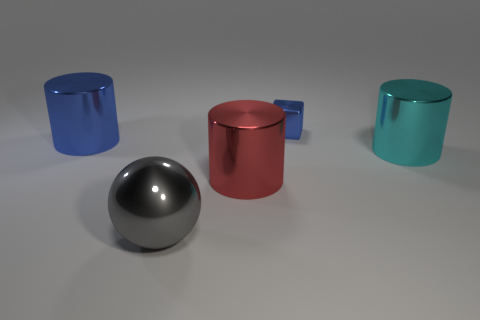Is there any other thing that is the same color as the big metallic sphere?
Offer a very short reply. No. The metal cube has what color?
Your response must be concise. Blue. Are any green metal cylinders visible?
Your response must be concise. No. Are there any big blue metallic things right of the big cyan metallic cylinder?
Keep it short and to the point. No. What material is the large blue thing that is the same shape as the large red object?
Offer a terse response. Metal. Are there any other things that are the same material as the large gray ball?
Ensure brevity in your answer.  Yes. What number of other things are there of the same shape as the small blue thing?
Make the answer very short. 0. There is a thing behind the big object on the left side of the shiny ball; how many big cylinders are on the left side of it?
Ensure brevity in your answer.  2. What number of other big shiny objects are the same shape as the big gray thing?
Your answer should be compact. 0. Does the metal cylinder that is left of the red metal cylinder have the same color as the sphere?
Keep it short and to the point. No. 